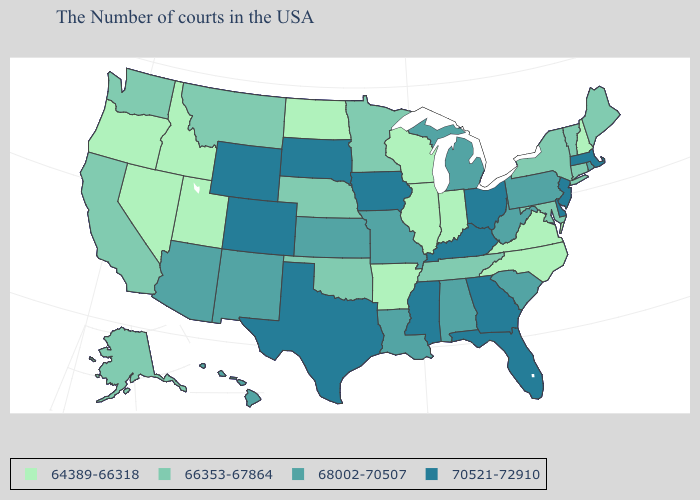What is the value of Minnesota?
Short answer required. 66353-67864. Name the states that have a value in the range 68002-70507?
Keep it brief. Rhode Island, Pennsylvania, South Carolina, West Virginia, Michigan, Alabama, Louisiana, Missouri, Kansas, New Mexico, Arizona, Hawaii. What is the value of Hawaii?
Answer briefly. 68002-70507. How many symbols are there in the legend?
Short answer required. 4. Does Iowa have the highest value in the MidWest?
Give a very brief answer. Yes. Name the states that have a value in the range 68002-70507?
Concise answer only. Rhode Island, Pennsylvania, South Carolina, West Virginia, Michigan, Alabama, Louisiana, Missouri, Kansas, New Mexico, Arizona, Hawaii. What is the value of New Hampshire?
Be succinct. 64389-66318. What is the lowest value in states that border Pennsylvania?
Write a very short answer. 66353-67864. Is the legend a continuous bar?
Be succinct. No. Does Washington have the same value as Rhode Island?
Short answer required. No. What is the value of New York?
Keep it brief. 66353-67864. Does Colorado have a higher value than Maine?
Keep it brief. Yes. Name the states that have a value in the range 70521-72910?
Concise answer only. Massachusetts, New Jersey, Delaware, Ohio, Florida, Georgia, Kentucky, Mississippi, Iowa, Texas, South Dakota, Wyoming, Colorado. Which states hav the highest value in the South?
Keep it brief. Delaware, Florida, Georgia, Kentucky, Mississippi, Texas. Does Arizona have a lower value than South Carolina?
Concise answer only. No. 